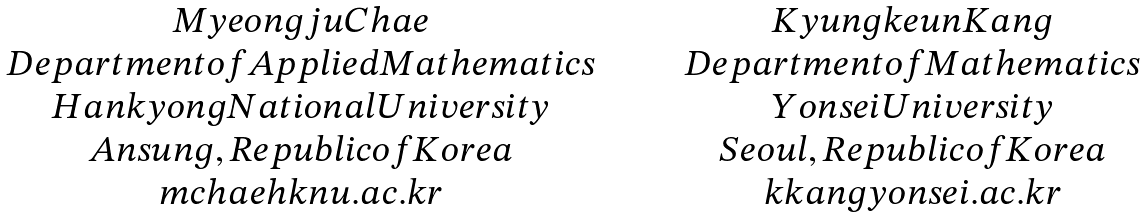Convert formula to latex. <formula><loc_0><loc_0><loc_500><loc_500>\begin{array} { c c } { M y e o n g j u C h a e } \quad & \quad { K y u n g k e u n K a n g } \\ { D e p a r t m e n t o f A p p l i e d M a t h e m a t i c s } \quad & \quad { D e p a r t m e n t o f M a t h e m a t i c s } \\ { H a n k y o n g N a t i o n a l U n i v e r s i t y } \quad & \quad { Y o n s e i U n i v e r s i t y } \\ { A n s u n g , R e p u b l i c o f K o r e a } \quad & \quad { S e o u l , R e p u b l i c o f K o r e a } \\ { m c h a e h k n u . a c . k r } \quad & \quad { k k a n g y o n s e i . a c . k r } \end{array}</formula> 